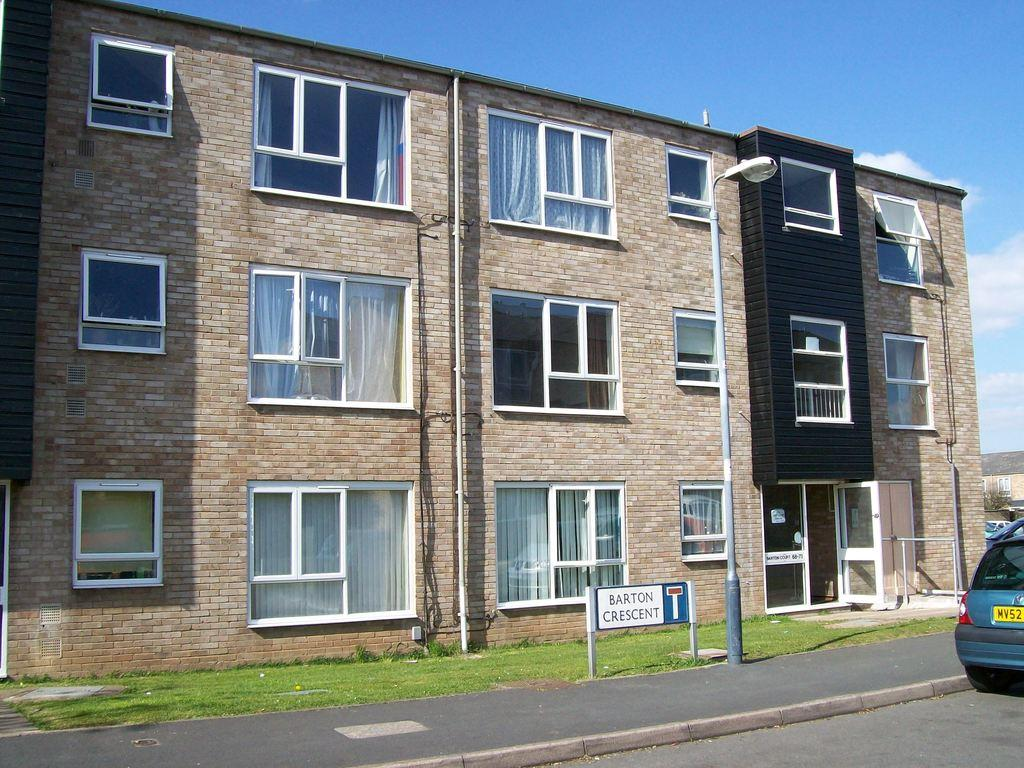What type of structure is present in the image? There is a building in the image. What mode of transportation can be seen on the road? A car is visible on the road in the image. What type of natural environment is located beside the road? There is a garden beside the road in the image. What is visible in the background of the image? The sky is visible in the image. What atmospheric feature can be seen in the sky? Clouds are present in the sky. What type of bottle is being used by the organization in the image? There is no bottle or organization present in the image. How does the image capture the attention of the viewer? The image itself does not have the ability to capture the attention of the viewer; it is a static representation of the scene. 